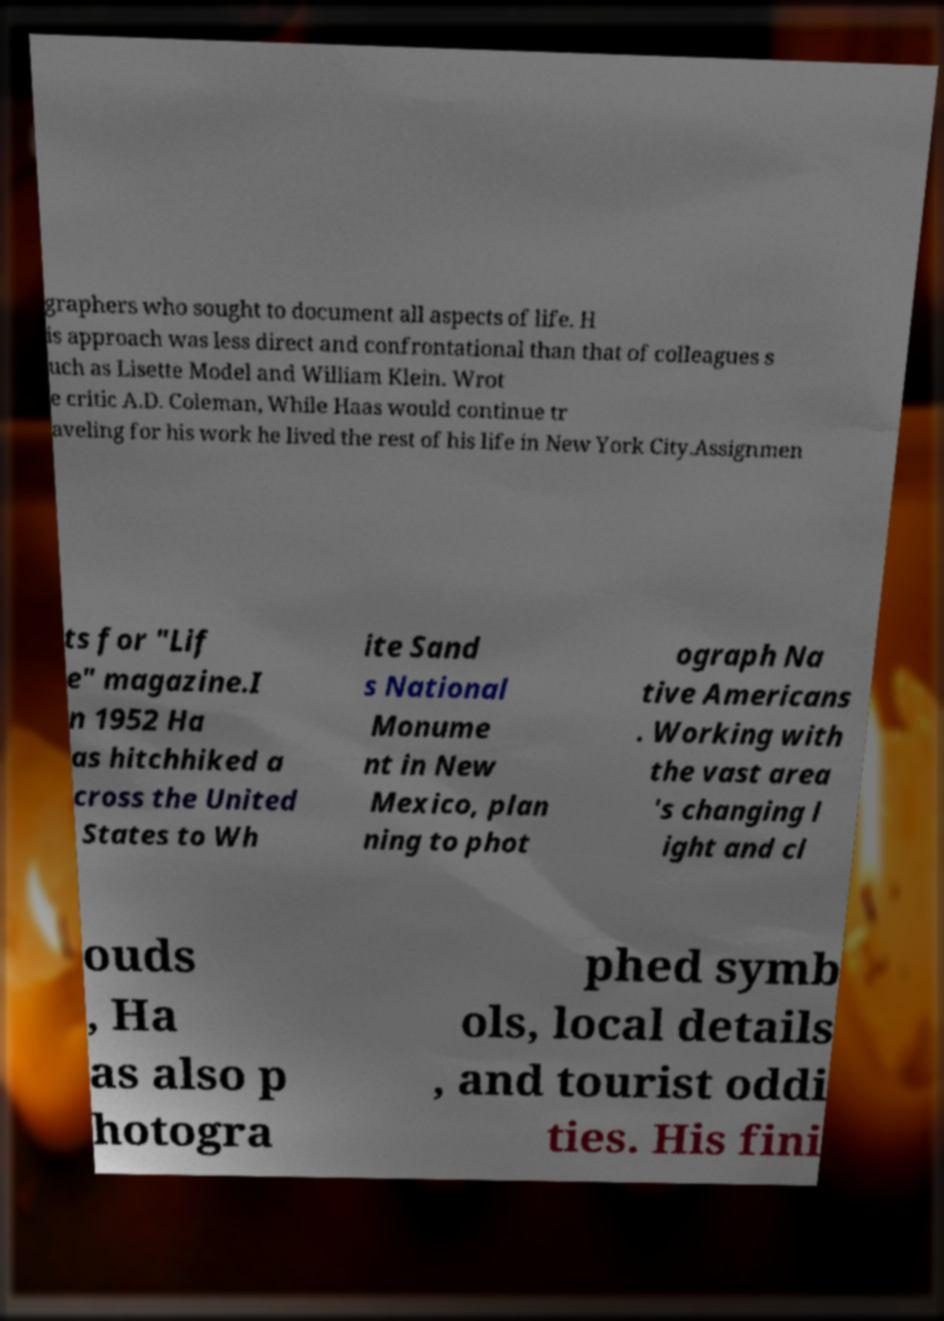Can you accurately transcribe the text from the provided image for me? graphers who sought to document all aspects of life. H is approach was less direct and confrontational than that of colleagues s uch as Lisette Model and William Klein. Wrot e critic A.D. Coleman, While Haas would continue tr aveling for his work he lived the rest of his life in New York City.Assignmen ts for "Lif e" magazine.I n 1952 Ha as hitchhiked a cross the United States to Wh ite Sand s National Monume nt in New Mexico, plan ning to phot ograph Na tive Americans . Working with the vast area 's changing l ight and cl ouds , Ha as also p hotogra phed symb ols, local details , and tourist oddi ties. His fini 